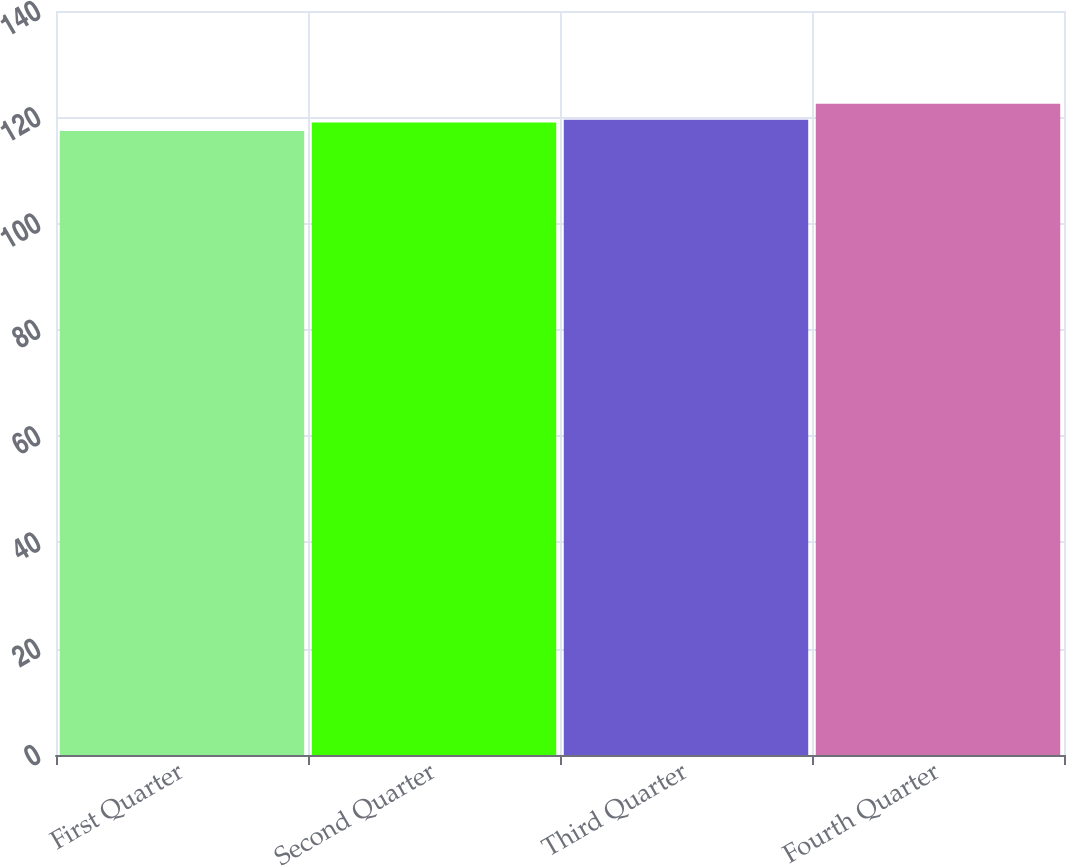Convert chart to OTSL. <chart><loc_0><loc_0><loc_500><loc_500><bar_chart><fcel>First Quarter<fcel>Second Quarter<fcel>Third Quarter<fcel>Fourth Quarter<nl><fcel>117.43<fcel>119.04<fcel>119.55<fcel>122.57<nl></chart> 